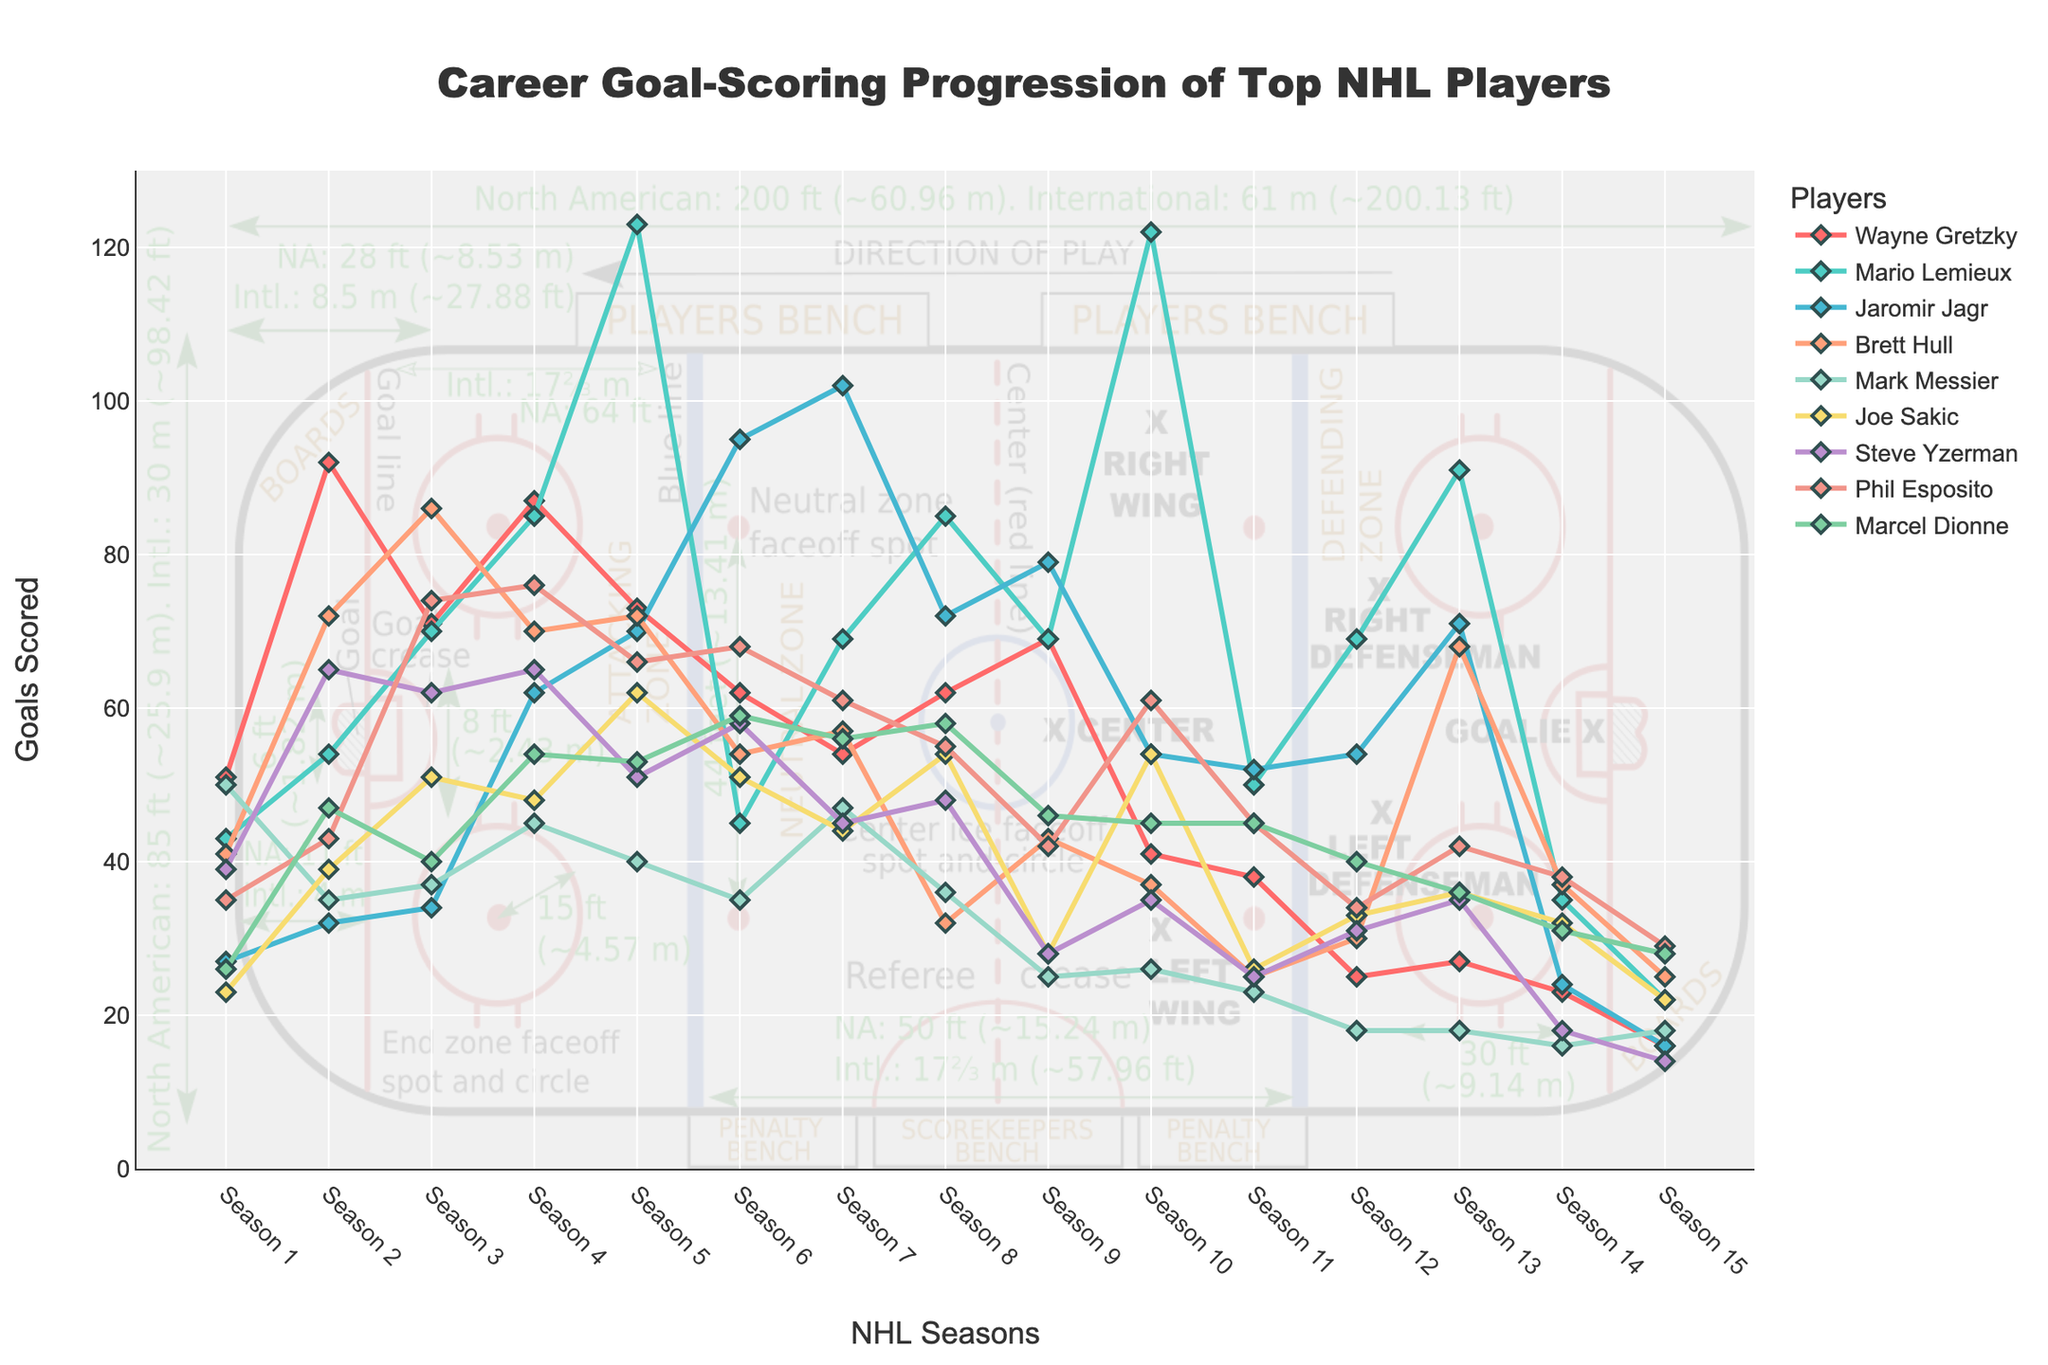What's the total number of goals Wayne Gretzky scored over the 15 seasons? Sum all the goals scored by Wayne Gretzky across all 15 seasons: 51 + 92 + 71 + 87 + 73 + 62 + 54 + 62 + 69 + 41 + 38 + 25 + 27 + 23 + 16 = 791
Answer: 791 Which player scored the highest number of goals in a single season, and in which season was it? Look for the maximum value in the data table across all players and identify the corresponding player and season. Mario Lemieux scored 123 goals in Season 5.
Answer: Mario Lemieux, Season 5 Between Brett Hull and Joe Sakic, who had more consistent goal-scoring, and how is consistency visually determined? Consistency can be visualized by observing the fluctuation in the lines. Joe Sakic's line shows smaller fluctuations in goal counts than Brett Hull's, indicating more consistent scoring.
Answer: Joe Sakic What's the average number of goals per season for Mark Messier over his 15-season career? Calculate the total goals scored by Mark Messier: 50 + 35 + 37 + 45 + 40 + 35 + 47 + 36 + 25 + 26 + 23 + 18 + 18 + 16 + 18 = 469. Then find the average by dividing by 15: 469/15 ≈ 31.27.
Answer: 31.27 How does Phil Esposito's goal-scoring trend over the 15 seasons compare to Marcel Dionne's? Compare the lines representing Phil Esposito and Marcel Dionne. Phil Esposito's goals have higher peaks in the middle seasons, while Marcel Dionne's scoring is more uniform with smaller peaks and less variation.
Answer: Phil Esposito has higher peaks; Marcel Dionne is more uniform Which player has the most fluctuating goal-scoring pattern? Visually identify which line has the largest variations in height over the seasons. Mario Lemieux’s line shows the most fluctuation due to the highs and lows across the seasons.
Answer: Mario Lemieux What is the mean number of goals Steve Yzerman scored in his best three seasons? Identify Steve Yzerman’s best three seasons in terms of goals scored: 65, 62, and 65. Calculate the mean of these values: (65 + 62 + 65)/3 = 64.
Answer: 64 Which player had the least decline in performance in the latter half of their career (last 7-8 seasons)? Analyze the slopes of the lines in the last 7-8 seasons of each player. Jaromir Jagr’s line shows smaller declines compared to others, indicating a less significant performance drop.
Answer: Jaromir Jagr What is the sum of goals scored by all players in Season 10? Add the number of goals scored by each player in Season 10: 41 + 122 + 54 + 37 + 26 + 54 + 35 + 61 + 45 = 475.
Answer: 475 How does the height of Wayne Gretzky's highest point compare to Brett Hull's highest point in the graph? Visually compare the two highest points: Wayne Gretzky's highest point is 92 goals (Season 2), and Brett Hull’s highest point is 86 goals (Season 3). 92 is greater than 86.
Answer: Wayne Gretzky's is higher 